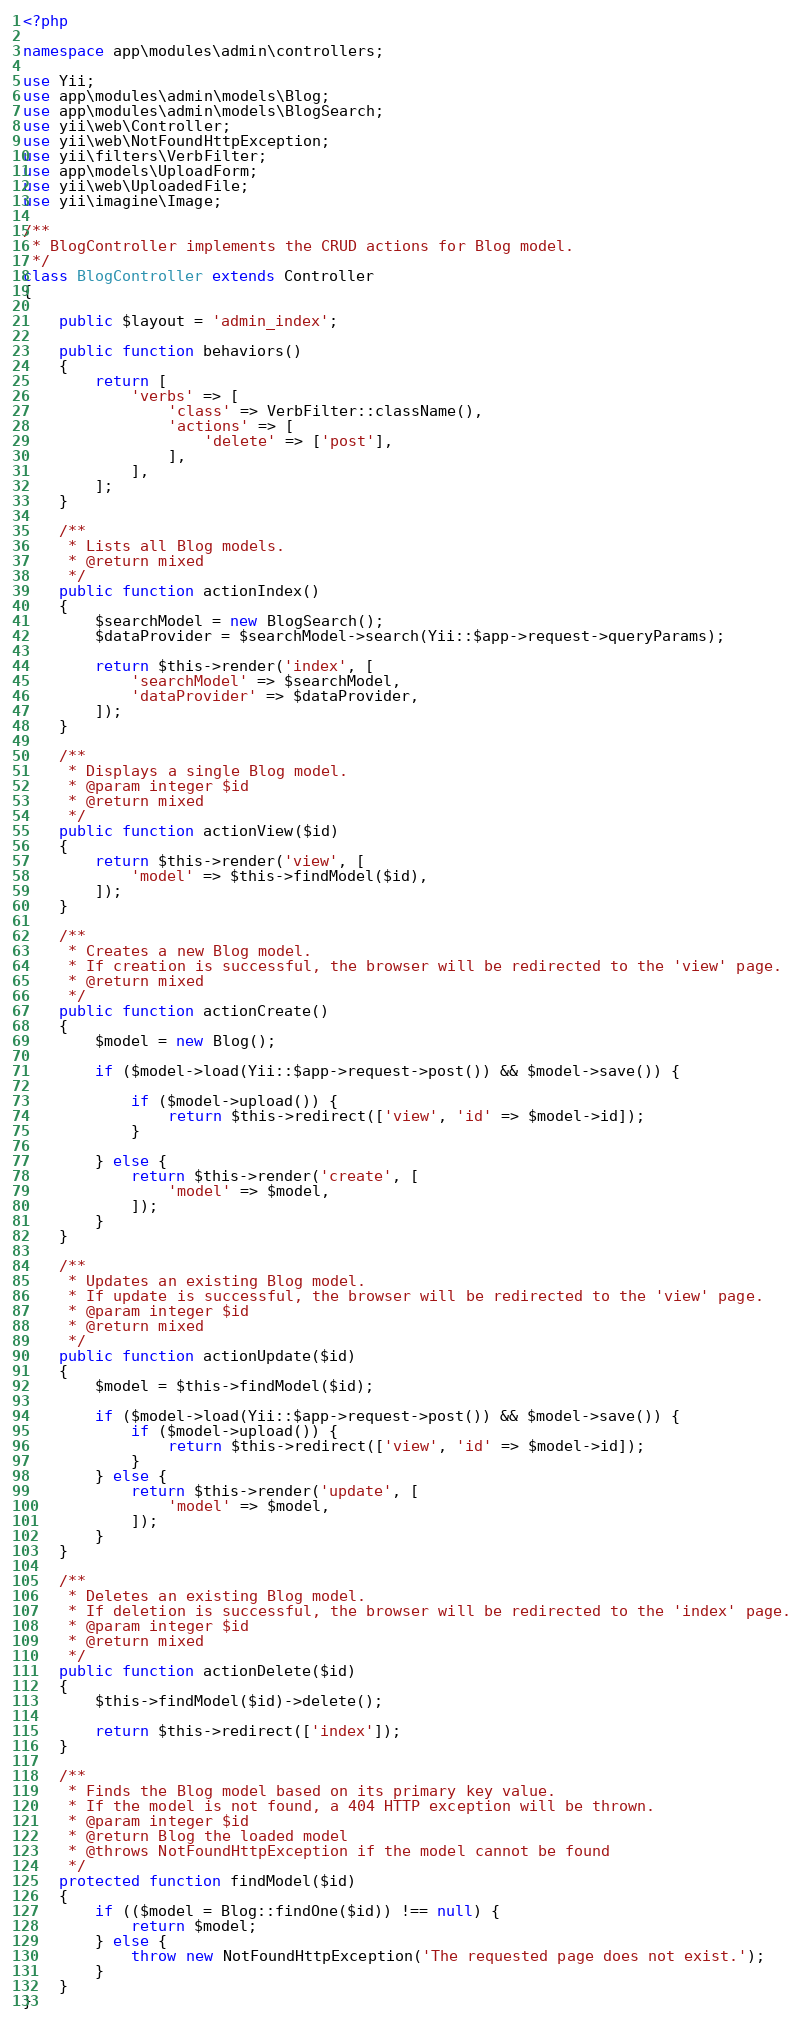<code> <loc_0><loc_0><loc_500><loc_500><_PHP_><?php

namespace app\modules\admin\controllers;

use Yii;
use app\modules\admin\models\Blog;
use app\modules\admin\models\BlogSearch;
use yii\web\Controller;
use yii\web\NotFoundHttpException;
use yii\filters\VerbFilter;
use app\models\UploadForm;
use yii\web\UploadedFile;
use yii\imagine\Image;

/**
 * BlogController implements the CRUD actions for Blog model.
 */
class BlogController extends Controller
{

    public $layout = 'admin_index';

    public function behaviors()
    {
        return [
            'verbs' => [
                'class' => VerbFilter::className(),
                'actions' => [
                    'delete' => ['post'],
                ],
            ],
        ];
    }

    /**
     * Lists all Blog models.
     * @return mixed
     */
    public function actionIndex()
    {
        $searchModel = new BlogSearch();
        $dataProvider = $searchModel->search(Yii::$app->request->queryParams);

        return $this->render('index', [
            'searchModel' => $searchModel,
            'dataProvider' => $dataProvider,
        ]);
    }

    /**
     * Displays a single Blog model.
     * @param integer $id
     * @return mixed
     */
    public function actionView($id)
    {
        return $this->render('view', [
            'model' => $this->findModel($id),
        ]);
    }

    /**
     * Creates a new Blog model.
     * If creation is successful, the browser will be redirected to the 'view' page.
     * @return mixed
     */
    public function actionCreate()
    {
        $model = new Blog();

        if ($model->load(Yii::$app->request->post()) && $model->save()) {

            if ($model->upload()) {
                return $this->redirect(['view', 'id' => $model->id]);
            }

        } else {
            return $this->render('create', [
                'model' => $model,
            ]);
        }
    }

    /**
     * Updates an existing Blog model.
     * If update is successful, the browser will be redirected to the 'view' page.
     * @param integer $id
     * @return mixed
     */
    public function actionUpdate($id)
    {
        $model = $this->findModel($id);

        if ($model->load(Yii::$app->request->post()) && $model->save()) {
            if ($model->upload()) {
                return $this->redirect(['view', 'id' => $model->id]);
            }
        } else {
            return $this->render('update', [
                'model' => $model,
            ]);
        }
    }

    /**
     * Deletes an existing Blog model.
     * If deletion is successful, the browser will be redirected to the 'index' page.
     * @param integer $id
     * @return mixed
     */
    public function actionDelete($id)
    {
        $this->findModel($id)->delete();

        return $this->redirect(['index']);
    }

    /**
     * Finds the Blog model based on its primary key value.
     * If the model is not found, a 404 HTTP exception will be thrown.
     * @param integer $id
     * @return Blog the loaded model
     * @throws NotFoundHttpException if the model cannot be found
     */
    protected function findModel($id)
    {
        if (($model = Blog::findOne($id)) !== null) {
            return $model;
        } else {
            throw new NotFoundHttpException('The requested page does not exist.');
        }
    }
}
</code> 